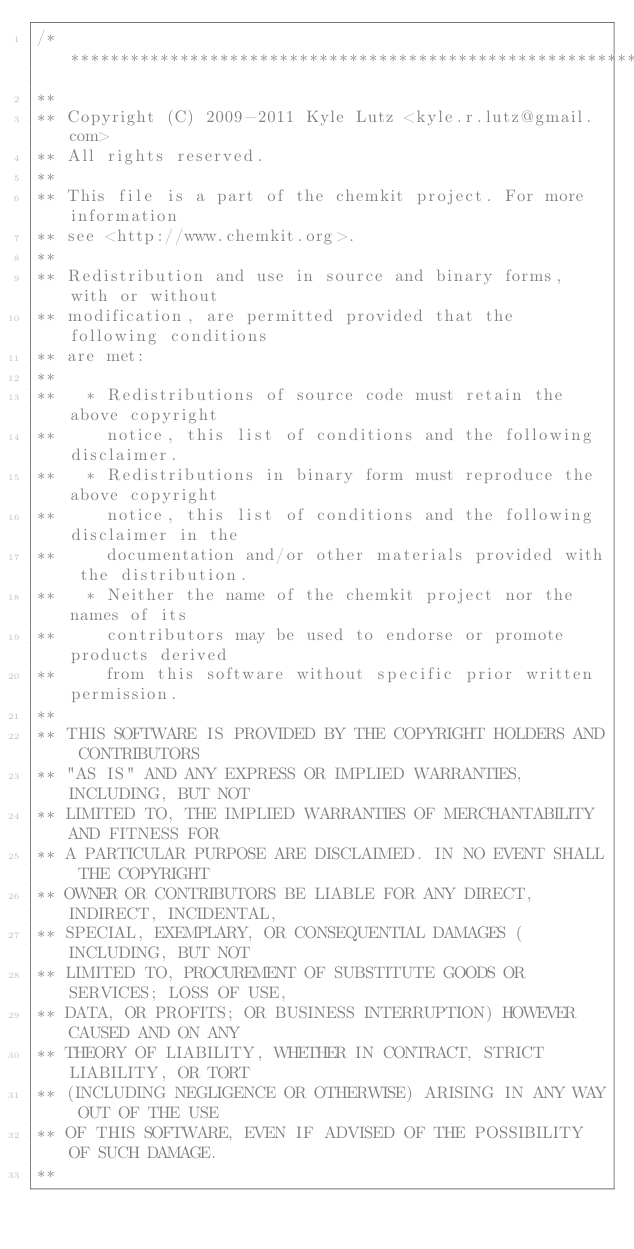<code> <loc_0><loc_0><loc_500><loc_500><_C++_>/******************************************************************************
**
** Copyright (C) 2009-2011 Kyle Lutz <kyle.r.lutz@gmail.com>
** All rights reserved.
**
** This file is a part of the chemkit project. For more information
** see <http://www.chemkit.org>.
**
** Redistribution and use in source and binary forms, with or without
** modification, are permitted provided that the following conditions
** are met:
**
**   * Redistributions of source code must retain the above copyright
**     notice, this list of conditions and the following disclaimer.
**   * Redistributions in binary form must reproduce the above copyright
**     notice, this list of conditions and the following disclaimer in the
**     documentation and/or other materials provided with the distribution.
**   * Neither the name of the chemkit project nor the names of its
**     contributors may be used to endorse or promote products derived
**     from this software without specific prior written permission.
**
** THIS SOFTWARE IS PROVIDED BY THE COPYRIGHT HOLDERS AND CONTRIBUTORS
** "AS IS" AND ANY EXPRESS OR IMPLIED WARRANTIES, INCLUDING, BUT NOT
** LIMITED TO, THE IMPLIED WARRANTIES OF MERCHANTABILITY AND FITNESS FOR
** A PARTICULAR PURPOSE ARE DISCLAIMED. IN NO EVENT SHALL THE COPYRIGHT
** OWNER OR CONTRIBUTORS BE LIABLE FOR ANY DIRECT, INDIRECT, INCIDENTAL,
** SPECIAL, EXEMPLARY, OR CONSEQUENTIAL DAMAGES (INCLUDING, BUT NOT
** LIMITED TO, PROCUREMENT OF SUBSTITUTE GOODS OR SERVICES; LOSS OF USE,
** DATA, OR PROFITS; OR BUSINESS INTERRUPTION) HOWEVER CAUSED AND ON ANY
** THEORY OF LIABILITY, WHETHER IN CONTRACT, STRICT LIABILITY, OR TORT
** (INCLUDING NEGLIGENCE OR OTHERWISE) ARISING IN ANY WAY OUT OF THE USE
** OF THIS SOFTWARE, EVEN IF ADVISED OF THE POSSIBILITY OF SUCH DAMAGE.
**</code> 